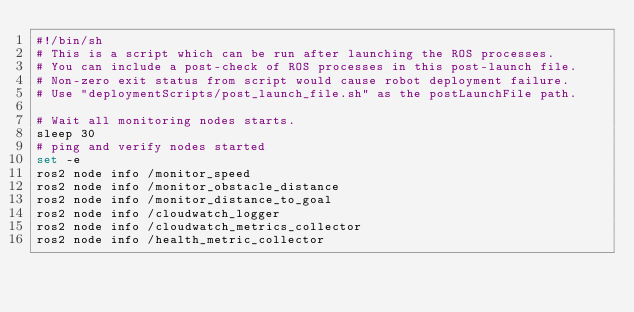<code> <loc_0><loc_0><loc_500><loc_500><_Bash_>#!/bin/sh
# This is a script which can be run after launching the ROS processes.
# You can include a post-check of ROS processes in this post-launch file. 
# Non-zero exit status from script would cause robot deployment failure. 
# Use "deploymentScripts/post_launch_file.sh" as the postLaunchFile path.

# Wait all monitoring nodes starts.
sleep 30
# ping and verify nodes started
set -e
ros2 node info /monitor_speed
ros2 node info /monitor_obstacle_distance
ros2 node info /monitor_distance_to_goal
ros2 node info /cloudwatch_logger
ros2 node info /cloudwatch_metrics_collector
ros2 node info /health_metric_collector
</code> 